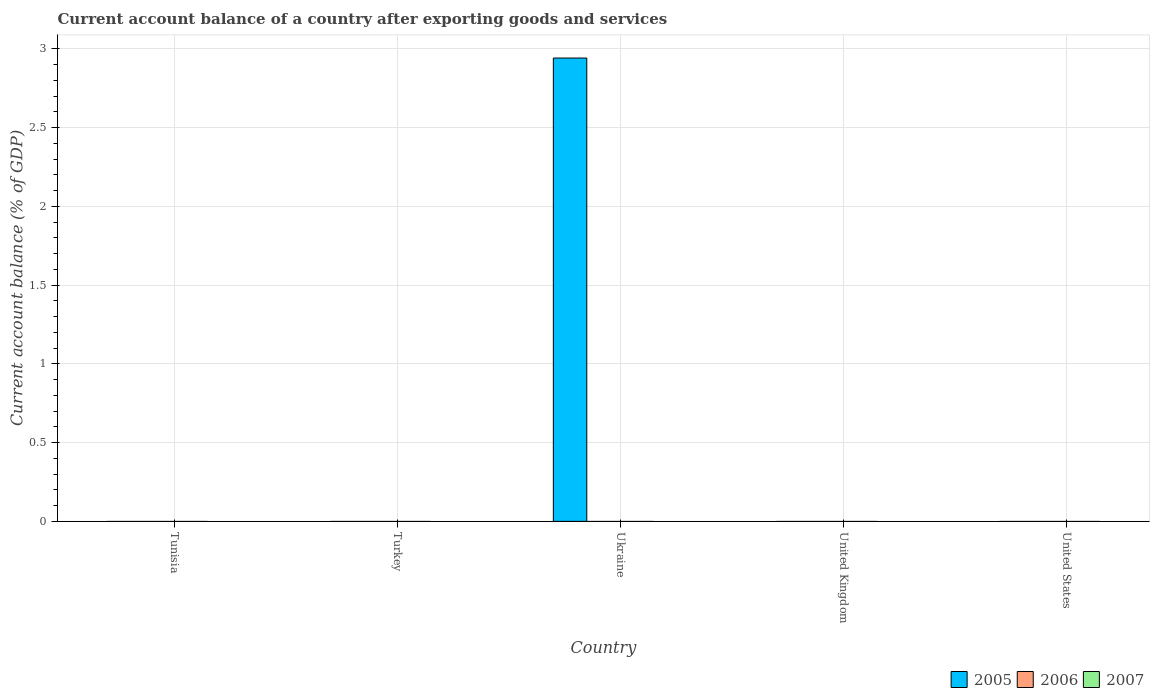How many different coloured bars are there?
Offer a very short reply. 1. How many bars are there on the 2nd tick from the right?
Your response must be concise. 0. What is the average account balance in 2005 per country?
Your answer should be compact. 0.59. In how many countries, is the account balance in 2007 greater than 1.8 %?
Your response must be concise. 0. What is the difference between the highest and the lowest account balance in 2005?
Your response must be concise. 2.94. Is it the case that in every country, the sum of the account balance in 2005 and account balance in 2007 is greater than the account balance in 2006?
Provide a succinct answer. No. Are all the bars in the graph horizontal?
Your response must be concise. No. How many countries are there in the graph?
Your answer should be compact. 5. What is the difference between two consecutive major ticks on the Y-axis?
Keep it short and to the point. 0.5. Are the values on the major ticks of Y-axis written in scientific E-notation?
Offer a very short reply. No. Does the graph contain any zero values?
Your response must be concise. Yes. How are the legend labels stacked?
Ensure brevity in your answer.  Horizontal. What is the title of the graph?
Offer a very short reply. Current account balance of a country after exporting goods and services. Does "2007" appear as one of the legend labels in the graph?
Provide a succinct answer. Yes. What is the label or title of the X-axis?
Your answer should be compact. Country. What is the label or title of the Y-axis?
Offer a very short reply. Current account balance (% of GDP). What is the Current account balance (% of GDP) of 2005 in Tunisia?
Keep it short and to the point. 0. What is the Current account balance (% of GDP) in 2007 in Tunisia?
Your answer should be compact. 0. What is the Current account balance (% of GDP) in 2005 in Ukraine?
Your answer should be compact. 2.94. What is the Current account balance (% of GDP) of 2007 in Ukraine?
Ensure brevity in your answer.  0. What is the Current account balance (% of GDP) in 2005 in United Kingdom?
Offer a very short reply. 0. What is the Current account balance (% of GDP) of 2006 in United Kingdom?
Your answer should be very brief. 0. What is the Current account balance (% of GDP) in 2005 in United States?
Make the answer very short. 0. What is the Current account balance (% of GDP) of 2006 in United States?
Make the answer very short. 0. What is the Current account balance (% of GDP) of 2007 in United States?
Your answer should be compact. 0. Across all countries, what is the maximum Current account balance (% of GDP) in 2005?
Offer a very short reply. 2.94. Across all countries, what is the minimum Current account balance (% of GDP) of 2005?
Offer a very short reply. 0. What is the total Current account balance (% of GDP) of 2005 in the graph?
Provide a short and direct response. 2.94. What is the total Current account balance (% of GDP) in 2006 in the graph?
Ensure brevity in your answer.  0. What is the average Current account balance (% of GDP) of 2005 per country?
Offer a very short reply. 0.59. What is the difference between the highest and the lowest Current account balance (% of GDP) of 2005?
Offer a terse response. 2.94. 